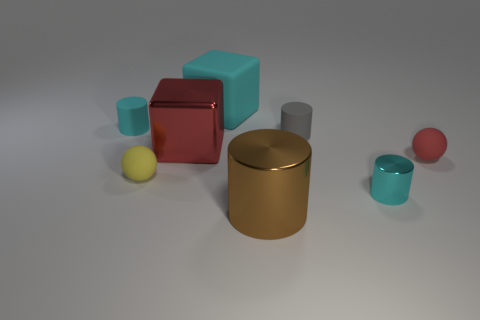Add 2 red metal blocks. How many objects exist? 10 Subtract all blocks. How many objects are left? 6 Subtract 0 green cylinders. How many objects are left? 8 Subtract all big red rubber cylinders. Subtract all rubber blocks. How many objects are left? 7 Add 1 large brown cylinders. How many large brown cylinders are left? 2 Add 4 small cylinders. How many small cylinders exist? 7 